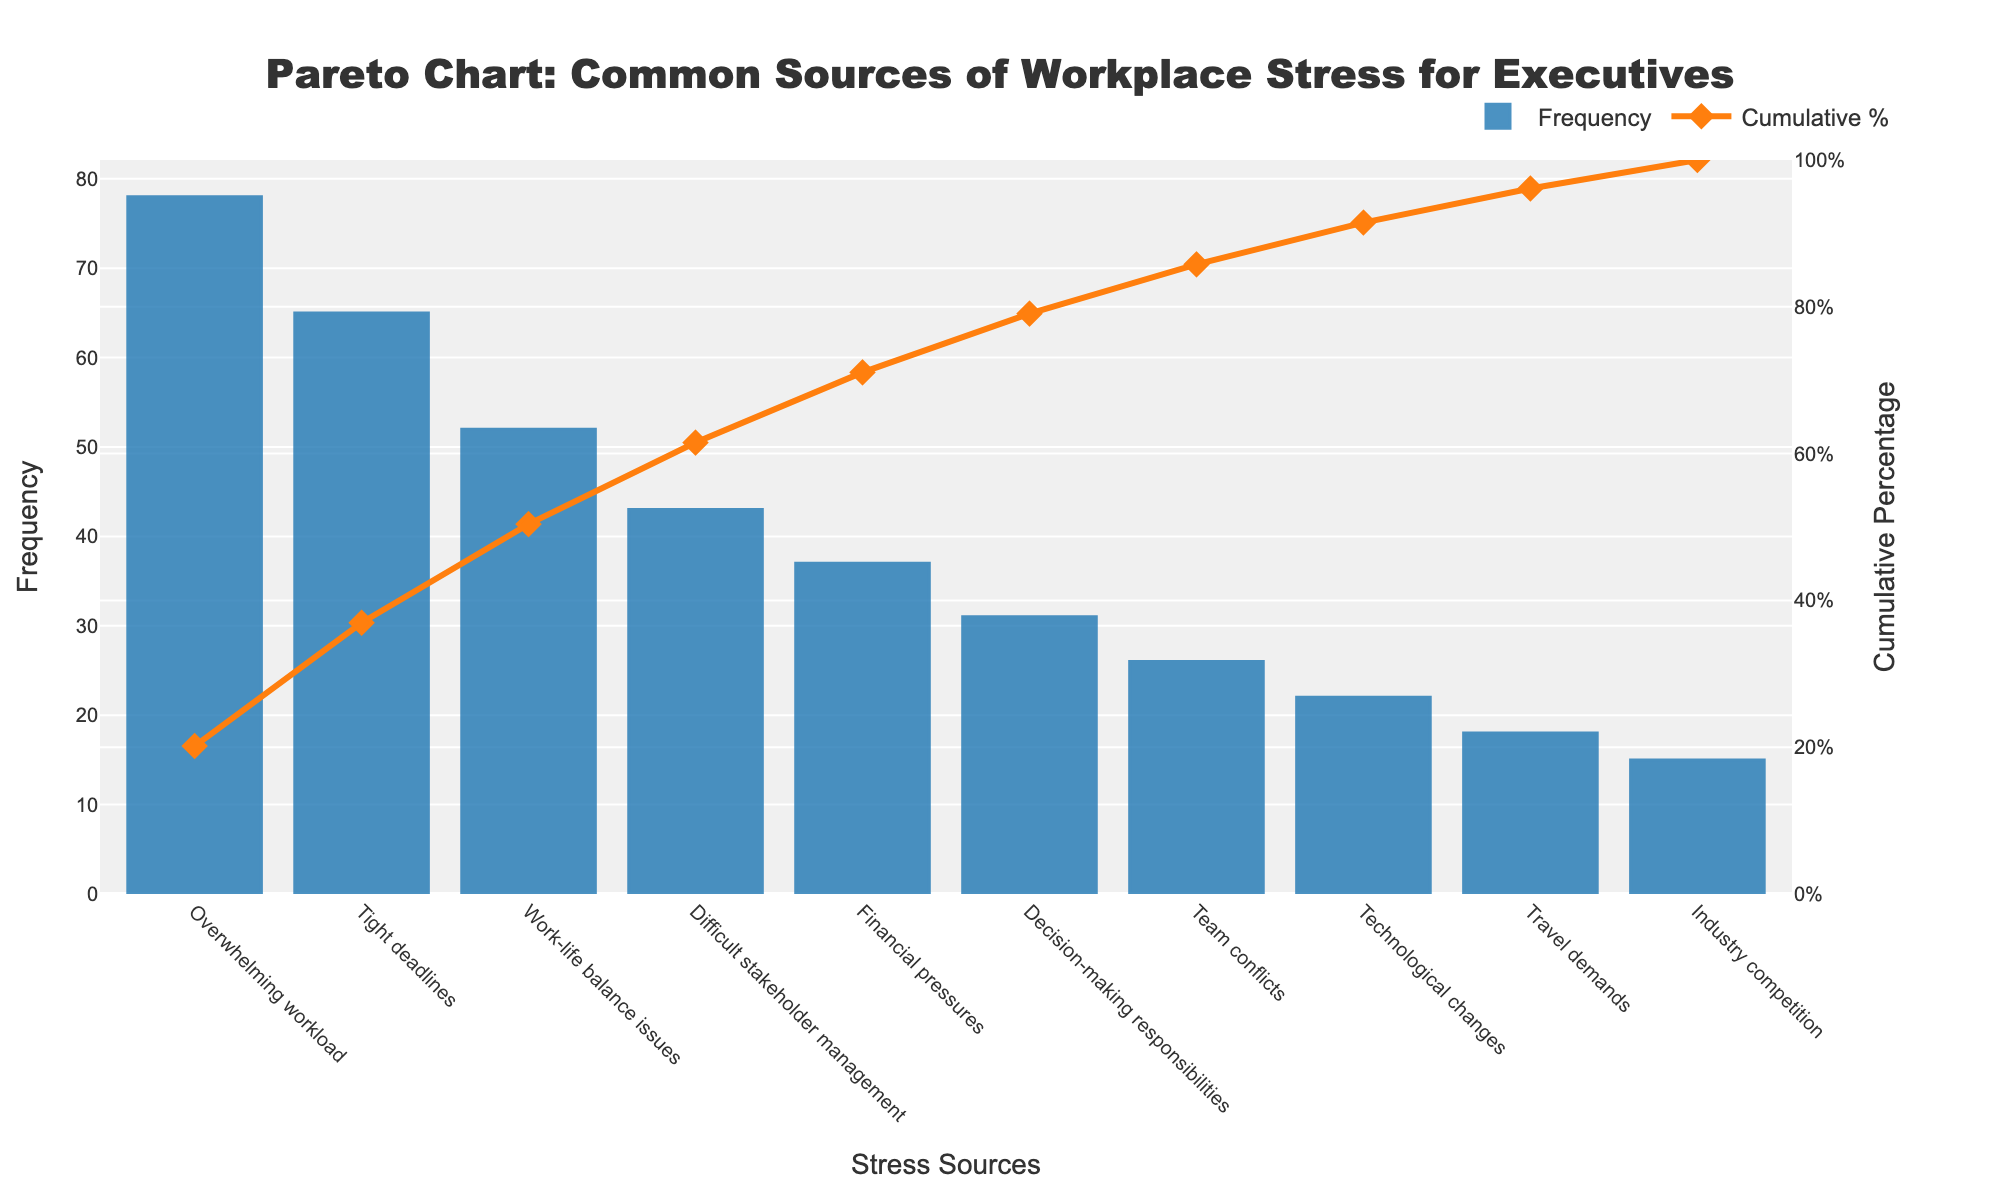what is the title of the figure? The title is placed at the top center of the chart and typically describes the primary subject of the figure. Here, it reads "Pareto Chart: Common Sources of Workplace Stress for Executives".
Answer: Pareto Chart: Common Sources of Workplace Stress for Executives How many sources of workplace stress are listed? Count the number of bars on the x-axis, each representing a different source of workplace stress for executives. There are 10 in total.
Answer: 10 Which source of stress has the highest frequency? Look at the height of the bars. The tallest bar represents the source with the highest frequency. The label below this bar indicates "Overwhelming workload".
Answer: Overwhelming workload What is the cumulative percentage for Decision-making responsibilities? Find the bar labeled "Decision-making responsibilities" on the x-axis, then look at the point where the corresponding line crosses the cumulative percentage axis. It reads close to 82%.
Answer: 82% How much more frequent is Tight deadlines compared to Industry competition? Identify the frequencies for "Tight deadlines" (65) and "Industry competition" (15). Subtract the frequency of Industry competition from the frequency of Tight deadlines: 65 - 15 = 50.
Answer: 50 Which source of stress contributes to the first 80% of cumulative percentage? Look at the Cumulative Percentage line and locate the point where it crosses the 80% mark. The corresponding sources of stress before this point are included. "Decision-making responsibilities" is around the 82% mark, so any source listed before this is included.
Answer: Decision-making responsibilities and earlier sources What is the total frequency of stress sources listed? Sum the frequencies of all bars: 78 + 65 + 52 + 43 + 37 + 31 + 26 + 22 + 18 + 15 = 387.
Answer: 387 Compare the cumulative percentage between Team conflicts and Technological changes. Locate the bars for "Team conflicts" and "Technological changes". Note where the line chart intersects the y-axis for each. Team conflicts are around 88% and Technological changes are around 94%. So, 94% - 88% = 6%.
Answer: 6% How does the color and style differentiate Frequency and Cumulative Percentage? The bars are blue (Frequency) and the line is orange with diamond markers (Cumulative Percentage). These stylistic choices make it easy to distinguish between the count of individual stress sources and their cumulative impact.
Answer: Bars are blue, line is orange with diamond markers Why is the secondary y-axis important in this chart? The secondary y-axis (right side) displays the cumulative percentage, allowing the viewer to see both individual frequencies of stress sources and their cumulative impacts on the same chart, which aids in identifying the most critical stressors effectively.
Answer: To display cumulative percentage 